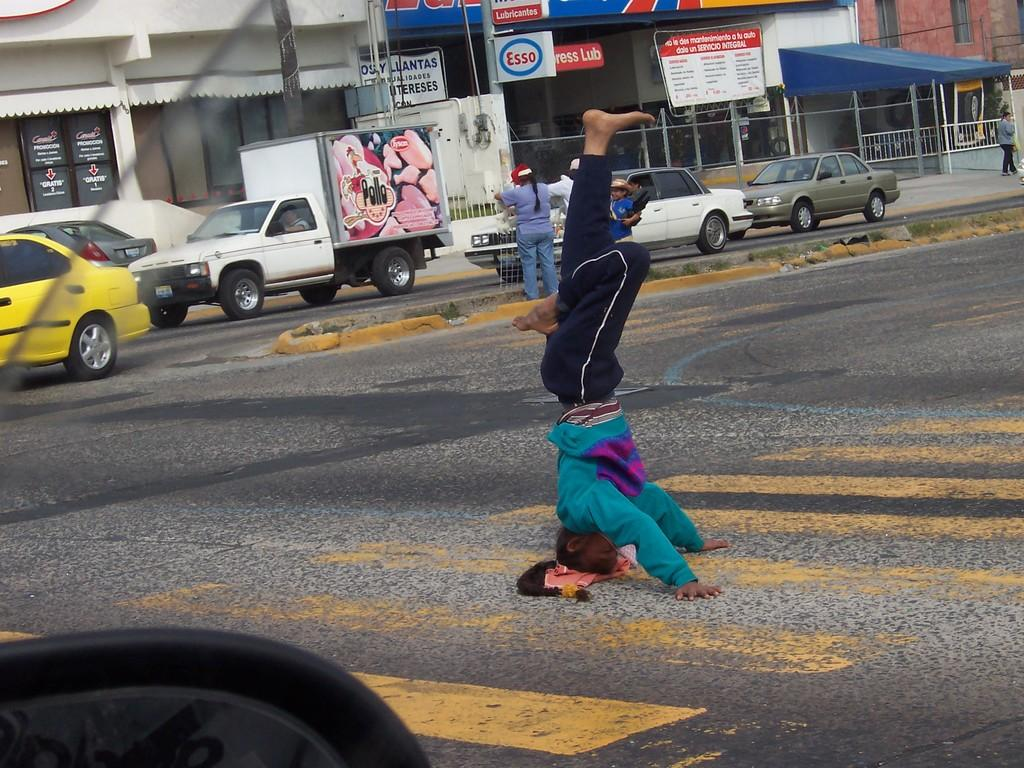Provide a one-sentence caption for the provided image. A man stands on his head in the middle of a crosswalk with a Pollo truck in the background. 